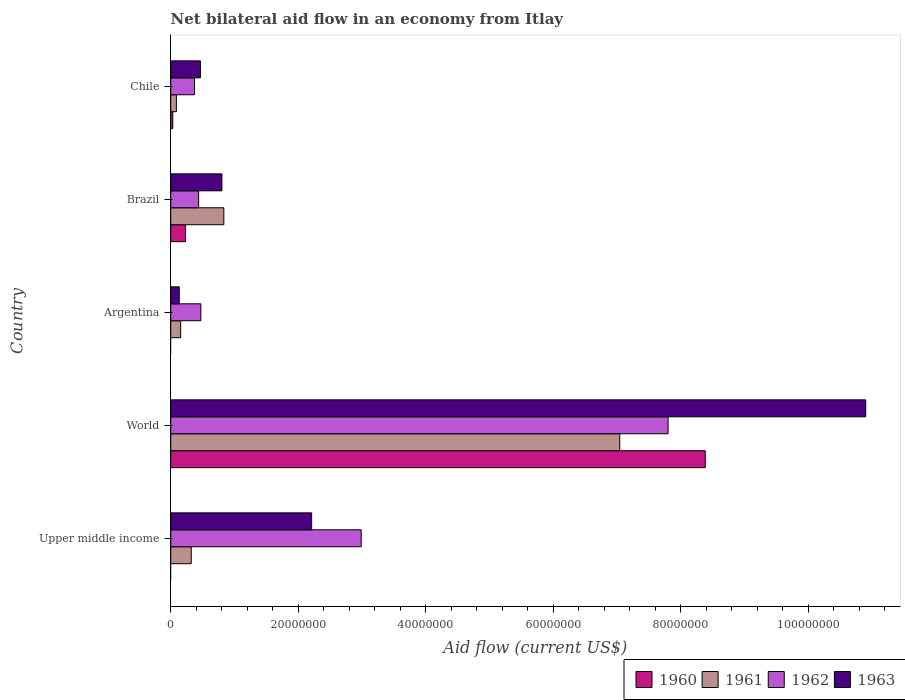How many different coloured bars are there?
Give a very brief answer. 4. How many groups of bars are there?
Your answer should be very brief. 5. Are the number of bars on each tick of the Y-axis equal?
Keep it short and to the point. No. How many bars are there on the 4th tick from the top?
Your answer should be compact. 4. In how many cases, is the number of bars for a given country not equal to the number of legend labels?
Your answer should be very brief. 2. What is the net bilateral aid flow in 1961 in Brazil?
Give a very brief answer. 8.33e+06. Across all countries, what is the maximum net bilateral aid flow in 1960?
Offer a terse response. 8.38e+07. Across all countries, what is the minimum net bilateral aid flow in 1962?
Provide a succinct answer. 3.73e+06. In which country was the net bilateral aid flow in 1962 maximum?
Provide a succinct answer. World. What is the total net bilateral aid flow in 1961 in the graph?
Your response must be concise. 8.44e+07. What is the difference between the net bilateral aid flow in 1963 in Upper middle income and that in World?
Ensure brevity in your answer.  -8.69e+07. What is the difference between the net bilateral aid flow in 1961 in Chile and the net bilateral aid flow in 1960 in Brazil?
Your answer should be very brief. -1.43e+06. What is the average net bilateral aid flow in 1962 per country?
Make the answer very short. 2.41e+07. What is the difference between the net bilateral aid flow in 1963 and net bilateral aid flow in 1962 in Brazil?
Provide a succinct answer. 3.65e+06. What is the ratio of the net bilateral aid flow in 1960 in Brazil to that in Chile?
Your answer should be very brief. 7.25. Is the net bilateral aid flow in 1962 in Chile less than that in World?
Your answer should be compact. Yes. What is the difference between the highest and the second highest net bilateral aid flow in 1963?
Keep it short and to the point. 8.69e+07. What is the difference between the highest and the lowest net bilateral aid flow in 1960?
Make the answer very short. 8.38e+07. In how many countries, is the net bilateral aid flow in 1961 greater than the average net bilateral aid flow in 1961 taken over all countries?
Your answer should be compact. 1. Is it the case that in every country, the sum of the net bilateral aid flow in 1963 and net bilateral aid flow in 1961 is greater than the net bilateral aid flow in 1960?
Provide a short and direct response. Yes. How many bars are there?
Make the answer very short. 18. Are all the bars in the graph horizontal?
Offer a terse response. Yes. Does the graph contain any zero values?
Ensure brevity in your answer.  Yes. Where does the legend appear in the graph?
Provide a short and direct response. Bottom right. How many legend labels are there?
Provide a succinct answer. 4. How are the legend labels stacked?
Offer a terse response. Horizontal. What is the title of the graph?
Your response must be concise. Net bilateral aid flow in an economy from Itlay. What is the label or title of the X-axis?
Your answer should be compact. Aid flow (current US$). What is the label or title of the Y-axis?
Offer a very short reply. Country. What is the Aid flow (current US$) of 1960 in Upper middle income?
Offer a terse response. 0. What is the Aid flow (current US$) of 1961 in Upper middle income?
Provide a succinct answer. 3.22e+06. What is the Aid flow (current US$) in 1962 in Upper middle income?
Offer a very short reply. 2.99e+07. What is the Aid flow (current US$) in 1963 in Upper middle income?
Your answer should be compact. 2.21e+07. What is the Aid flow (current US$) in 1960 in World?
Ensure brevity in your answer.  8.38e+07. What is the Aid flow (current US$) of 1961 in World?
Provide a succinct answer. 7.04e+07. What is the Aid flow (current US$) of 1962 in World?
Ensure brevity in your answer.  7.80e+07. What is the Aid flow (current US$) in 1963 in World?
Provide a short and direct response. 1.09e+08. What is the Aid flow (current US$) in 1960 in Argentina?
Your answer should be very brief. 0. What is the Aid flow (current US$) in 1961 in Argentina?
Your response must be concise. 1.56e+06. What is the Aid flow (current US$) of 1962 in Argentina?
Provide a short and direct response. 4.73e+06. What is the Aid flow (current US$) of 1963 in Argentina?
Your answer should be very brief. 1.34e+06. What is the Aid flow (current US$) in 1960 in Brazil?
Make the answer very short. 2.32e+06. What is the Aid flow (current US$) in 1961 in Brazil?
Your answer should be very brief. 8.33e+06. What is the Aid flow (current US$) of 1962 in Brazil?
Your answer should be compact. 4.38e+06. What is the Aid flow (current US$) of 1963 in Brazil?
Your response must be concise. 8.03e+06. What is the Aid flow (current US$) in 1961 in Chile?
Your response must be concise. 8.90e+05. What is the Aid flow (current US$) in 1962 in Chile?
Your answer should be very brief. 3.73e+06. What is the Aid flow (current US$) of 1963 in Chile?
Your response must be concise. 4.66e+06. Across all countries, what is the maximum Aid flow (current US$) of 1960?
Your answer should be very brief. 8.38e+07. Across all countries, what is the maximum Aid flow (current US$) in 1961?
Offer a terse response. 7.04e+07. Across all countries, what is the maximum Aid flow (current US$) in 1962?
Make the answer very short. 7.80e+07. Across all countries, what is the maximum Aid flow (current US$) in 1963?
Keep it short and to the point. 1.09e+08. Across all countries, what is the minimum Aid flow (current US$) of 1961?
Offer a terse response. 8.90e+05. Across all countries, what is the minimum Aid flow (current US$) of 1962?
Provide a succinct answer. 3.73e+06. Across all countries, what is the minimum Aid flow (current US$) of 1963?
Your answer should be very brief. 1.34e+06. What is the total Aid flow (current US$) of 1960 in the graph?
Make the answer very short. 8.65e+07. What is the total Aid flow (current US$) of 1961 in the graph?
Provide a short and direct response. 8.44e+07. What is the total Aid flow (current US$) in 1962 in the graph?
Offer a terse response. 1.21e+08. What is the total Aid flow (current US$) in 1963 in the graph?
Your answer should be compact. 1.45e+08. What is the difference between the Aid flow (current US$) of 1961 in Upper middle income and that in World?
Keep it short and to the point. -6.72e+07. What is the difference between the Aid flow (current US$) in 1962 in Upper middle income and that in World?
Your response must be concise. -4.81e+07. What is the difference between the Aid flow (current US$) of 1963 in Upper middle income and that in World?
Make the answer very short. -8.69e+07. What is the difference between the Aid flow (current US$) in 1961 in Upper middle income and that in Argentina?
Ensure brevity in your answer.  1.66e+06. What is the difference between the Aid flow (current US$) in 1962 in Upper middle income and that in Argentina?
Keep it short and to the point. 2.51e+07. What is the difference between the Aid flow (current US$) in 1963 in Upper middle income and that in Argentina?
Your response must be concise. 2.08e+07. What is the difference between the Aid flow (current US$) of 1961 in Upper middle income and that in Brazil?
Offer a very short reply. -5.11e+06. What is the difference between the Aid flow (current US$) of 1962 in Upper middle income and that in Brazil?
Ensure brevity in your answer.  2.55e+07. What is the difference between the Aid flow (current US$) of 1963 in Upper middle income and that in Brazil?
Provide a succinct answer. 1.41e+07. What is the difference between the Aid flow (current US$) in 1961 in Upper middle income and that in Chile?
Your answer should be compact. 2.33e+06. What is the difference between the Aid flow (current US$) of 1962 in Upper middle income and that in Chile?
Your answer should be compact. 2.61e+07. What is the difference between the Aid flow (current US$) of 1963 in Upper middle income and that in Chile?
Give a very brief answer. 1.74e+07. What is the difference between the Aid flow (current US$) in 1961 in World and that in Argentina?
Provide a short and direct response. 6.89e+07. What is the difference between the Aid flow (current US$) of 1962 in World and that in Argentina?
Your response must be concise. 7.33e+07. What is the difference between the Aid flow (current US$) in 1963 in World and that in Argentina?
Give a very brief answer. 1.08e+08. What is the difference between the Aid flow (current US$) in 1960 in World and that in Brazil?
Ensure brevity in your answer.  8.15e+07. What is the difference between the Aid flow (current US$) of 1961 in World and that in Brazil?
Ensure brevity in your answer.  6.21e+07. What is the difference between the Aid flow (current US$) in 1962 in World and that in Brazil?
Your answer should be compact. 7.36e+07. What is the difference between the Aid flow (current US$) in 1963 in World and that in Brazil?
Keep it short and to the point. 1.01e+08. What is the difference between the Aid flow (current US$) in 1960 in World and that in Chile?
Your answer should be compact. 8.35e+07. What is the difference between the Aid flow (current US$) of 1961 in World and that in Chile?
Your answer should be compact. 6.95e+07. What is the difference between the Aid flow (current US$) of 1962 in World and that in Chile?
Offer a terse response. 7.43e+07. What is the difference between the Aid flow (current US$) in 1963 in World and that in Chile?
Your answer should be compact. 1.04e+08. What is the difference between the Aid flow (current US$) in 1961 in Argentina and that in Brazil?
Keep it short and to the point. -6.77e+06. What is the difference between the Aid flow (current US$) of 1962 in Argentina and that in Brazil?
Your response must be concise. 3.50e+05. What is the difference between the Aid flow (current US$) of 1963 in Argentina and that in Brazil?
Your response must be concise. -6.69e+06. What is the difference between the Aid flow (current US$) in 1961 in Argentina and that in Chile?
Offer a terse response. 6.70e+05. What is the difference between the Aid flow (current US$) of 1962 in Argentina and that in Chile?
Offer a very short reply. 1.00e+06. What is the difference between the Aid flow (current US$) in 1963 in Argentina and that in Chile?
Keep it short and to the point. -3.32e+06. What is the difference between the Aid flow (current US$) in 1961 in Brazil and that in Chile?
Your answer should be compact. 7.44e+06. What is the difference between the Aid flow (current US$) in 1962 in Brazil and that in Chile?
Make the answer very short. 6.50e+05. What is the difference between the Aid flow (current US$) in 1963 in Brazil and that in Chile?
Your response must be concise. 3.37e+06. What is the difference between the Aid flow (current US$) in 1961 in Upper middle income and the Aid flow (current US$) in 1962 in World?
Offer a terse response. -7.48e+07. What is the difference between the Aid flow (current US$) of 1961 in Upper middle income and the Aid flow (current US$) of 1963 in World?
Keep it short and to the point. -1.06e+08. What is the difference between the Aid flow (current US$) of 1962 in Upper middle income and the Aid flow (current US$) of 1963 in World?
Provide a succinct answer. -7.91e+07. What is the difference between the Aid flow (current US$) of 1961 in Upper middle income and the Aid flow (current US$) of 1962 in Argentina?
Your answer should be very brief. -1.51e+06. What is the difference between the Aid flow (current US$) in 1961 in Upper middle income and the Aid flow (current US$) in 1963 in Argentina?
Your answer should be very brief. 1.88e+06. What is the difference between the Aid flow (current US$) of 1962 in Upper middle income and the Aid flow (current US$) of 1963 in Argentina?
Your answer should be very brief. 2.85e+07. What is the difference between the Aid flow (current US$) of 1961 in Upper middle income and the Aid flow (current US$) of 1962 in Brazil?
Your answer should be very brief. -1.16e+06. What is the difference between the Aid flow (current US$) of 1961 in Upper middle income and the Aid flow (current US$) of 1963 in Brazil?
Your response must be concise. -4.81e+06. What is the difference between the Aid flow (current US$) in 1962 in Upper middle income and the Aid flow (current US$) in 1963 in Brazil?
Your answer should be very brief. 2.18e+07. What is the difference between the Aid flow (current US$) in 1961 in Upper middle income and the Aid flow (current US$) in 1962 in Chile?
Make the answer very short. -5.10e+05. What is the difference between the Aid flow (current US$) of 1961 in Upper middle income and the Aid flow (current US$) of 1963 in Chile?
Your answer should be very brief. -1.44e+06. What is the difference between the Aid flow (current US$) of 1962 in Upper middle income and the Aid flow (current US$) of 1963 in Chile?
Ensure brevity in your answer.  2.52e+07. What is the difference between the Aid flow (current US$) of 1960 in World and the Aid flow (current US$) of 1961 in Argentina?
Your response must be concise. 8.23e+07. What is the difference between the Aid flow (current US$) in 1960 in World and the Aid flow (current US$) in 1962 in Argentina?
Ensure brevity in your answer.  7.91e+07. What is the difference between the Aid flow (current US$) of 1960 in World and the Aid flow (current US$) of 1963 in Argentina?
Your response must be concise. 8.25e+07. What is the difference between the Aid flow (current US$) of 1961 in World and the Aid flow (current US$) of 1962 in Argentina?
Your response must be concise. 6.57e+07. What is the difference between the Aid flow (current US$) of 1961 in World and the Aid flow (current US$) of 1963 in Argentina?
Offer a terse response. 6.91e+07. What is the difference between the Aid flow (current US$) of 1962 in World and the Aid flow (current US$) of 1963 in Argentina?
Offer a terse response. 7.67e+07. What is the difference between the Aid flow (current US$) in 1960 in World and the Aid flow (current US$) in 1961 in Brazil?
Your answer should be compact. 7.55e+07. What is the difference between the Aid flow (current US$) of 1960 in World and the Aid flow (current US$) of 1962 in Brazil?
Offer a very short reply. 7.94e+07. What is the difference between the Aid flow (current US$) in 1960 in World and the Aid flow (current US$) in 1963 in Brazil?
Offer a terse response. 7.58e+07. What is the difference between the Aid flow (current US$) in 1961 in World and the Aid flow (current US$) in 1962 in Brazil?
Ensure brevity in your answer.  6.60e+07. What is the difference between the Aid flow (current US$) of 1961 in World and the Aid flow (current US$) of 1963 in Brazil?
Give a very brief answer. 6.24e+07. What is the difference between the Aid flow (current US$) in 1962 in World and the Aid flow (current US$) in 1963 in Brazil?
Offer a very short reply. 7.00e+07. What is the difference between the Aid flow (current US$) in 1960 in World and the Aid flow (current US$) in 1961 in Chile?
Your answer should be compact. 8.29e+07. What is the difference between the Aid flow (current US$) of 1960 in World and the Aid flow (current US$) of 1962 in Chile?
Give a very brief answer. 8.01e+07. What is the difference between the Aid flow (current US$) of 1960 in World and the Aid flow (current US$) of 1963 in Chile?
Your response must be concise. 7.92e+07. What is the difference between the Aid flow (current US$) of 1961 in World and the Aid flow (current US$) of 1962 in Chile?
Offer a terse response. 6.67e+07. What is the difference between the Aid flow (current US$) of 1961 in World and the Aid flow (current US$) of 1963 in Chile?
Offer a very short reply. 6.58e+07. What is the difference between the Aid flow (current US$) in 1962 in World and the Aid flow (current US$) in 1963 in Chile?
Your answer should be very brief. 7.33e+07. What is the difference between the Aid flow (current US$) in 1961 in Argentina and the Aid flow (current US$) in 1962 in Brazil?
Provide a succinct answer. -2.82e+06. What is the difference between the Aid flow (current US$) in 1961 in Argentina and the Aid flow (current US$) in 1963 in Brazil?
Keep it short and to the point. -6.47e+06. What is the difference between the Aid flow (current US$) in 1962 in Argentina and the Aid flow (current US$) in 1963 in Brazil?
Ensure brevity in your answer.  -3.30e+06. What is the difference between the Aid flow (current US$) of 1961 in Argentina and the Aid flow (current US$) of 1962 in Chile?
Offer a terse response. -2.17e+06. What is the difference between the Aid flow (current US$) in 1961 in Argentina and the Aid flow (current US$) in 1963 in Chile?
Offer a terse response. -3.10e+06. What is the difference between the Aid flow (current US$) in 1962 in Argentina and the Aid flow (current US$) in 1963 in Chile?
Make the answer very short. 7.00e+04. What is the difference between the Aid flow (current US$) of 1960 in Brazil and the Aid flow (current US$) of 1961 in Chile?
Keep it short and to the point. 1.43e+06. What is the difference between the Aid flow (current US$) of 1960 in Brazil and the Aid flow (current US$) of 1962 in Chile?
Give a very brief answer. -1.41e+06. What is the difference between the Aid flow (current US$) in 1960 in Brazil and the Aid flow (current US$) in 1963 in Chile?
Offer a very short reply. -2.34e+06. What is the difference between the Aid flow (current US$) in 1961 in Brazil and the Aid flow (current US$) in 1962 in Chile?
Offer a very short reply. 4.60e+06. What is the difference between the Aid flow (current US$) in 1961 in Brazil and the Aid flow (current US$) in 1963 in Chile?
Make the answer very short. 3.67e+06. What is the difference between the Aid flow (current US$) in 1962 in Brazil and the Aid flow (current US$) in 1963 in Chile?
Your answer should be very brief. -2.80e+05. What is the average Aid flow (current US$) in 1960 per country?
Your answer should be very brief. 1.73e+07. What is the average Aid flow (current US$) in 1961 per country?
Make the answer very short. 1.69e+07. What is the average Aid flow (current US$) in 1962 per country?
Your answer should be very brief. 2.41e+07. What is the average Aid flow (current US$) in 1963 per country?
Keep it short and to the point. 2.90e+07. What is the difference between the Aid flow (current US$) of 1961 and Aid flow (current US$) of 1962 in Upper middle income?
Give a very brief answer. -2.66e+07. What is the difference between the Aid flow (current US$) in 1961 and Aid flow (current US$) in 1963 in Upper middle income?
Offer a very short reply. -1.89e+07. What is the difference between the Aid flow (current US$) of 1962 and Aid flow (current US$) of 1963 in Upper middle income?
Provide a succinct answer. 7.77e+06. What is the difference between the Aid flow (current US$) of 1960 and Aid flow (current US$) of 1961 in World?
Offer a terse response. 1.34e+07. What is the difference between the Aid flow (current US$) in 1960 and Aid flow (current US$) in 1962 in World?
Offer a terse response. 5.83e+06. What is the difference between the Aid flow (current US$) in 1960 and Aid flow (current US$) in 1963 in World?
Offer a terse response. -2.52e+07. What is the difference between the Aid flow (current US$) in 1961 and Aid flow (current US$) in 1962 in World?
Offer a terse response. -7.58e+06. What is the difference between the Aid flow (current US$) in 1961 and Aid flow (current US$) in 1963 in World?
Make the answer very short. -3.86e+07. What is the difference between the Aid flow (current US$) of 1962 and Aid flow (current US$) of 1963 in World?
Your answer should be very brief. -3.10e+07. What is the difference between the Aid flow (current US$) in 1961 and Aid flow (current US$) in 1962 in Argentina?
Your answer should be very brief. -3.17e+06. What is the difference between the Aid flow (current US$) of 1962 and Aid flow (current US$) of 1963 in Argentina?
Offer a terse response. 3.39e+06. What is the difference between the Aid flow (current US$) in 1960 and Aid flow (current US$) in 1961 in Brazil?
Your response must be concise. -6.01e+06. What is the difference between the Aid flow (current US$) in 1960 and Aid flow (current US$) in 1962 in Brazil?
Your answer should be very brief. -2.06e+06. What is the difference between the Aid flow (current US$) in 1960 and Aid flow (current US$) in 1963 in Brazil?
Give a very brief answer. -5.71e+06. What is the difference between the Aid flow (current US$) of 1961 and Aid flow (current US$) of 1962 in Brazil?
Give a very brief answer. 3.95e+06. What is the difference between the Aid flow (current US$) of 1961 and Aid flow (current US$) of 1963 in Brazil?
Ensure brevity in your answer.  3.00e+05. What is the difference between the Aid flow (current US$) of 1962 and Aid flow (current US$) of 1963 in Brazil?
Keep it short and to the point. -3.65e+06. What is the difference between the Aid flow (current US$) in 1960 and Aid flow (current US$) in 1961 in Chile?
Offer a very short reply. -5.70e+05. What is the difference between the Aid flow (current US$) in 1960 and Aid flow (current US$) in 1962 in Chile?
Offer a terse response. -3.41e+06. What is the difference between the Aid flow (current US$) of 1960 and Aid flow (current US$) of 1963 in Chile?
Offer a very short reply. -4.34e+06. What is the difference between the Aid flow (current US$) in 1961 and Aid flow (current US$) in 1962 in Chile?
Make the answer very short. -2.84e+06. What is the difference between the Aid flow (current US$) in 1961 and Aid flow (current US$) in 1963 in Chile?
Your answer should be very brief. -3.77e+06. What is the difference between the Aid flow (current US$) in 1962 and Aid flow (current US$) in 1963 in Chile?
Offer a very short reply. -9.30e+05. What is the ratio of the Aid flow (current US$) in 1961 in Upper middle income to that in World?
Keep it short and to the point. 0.05. What is the ratio of the Aid flow (current US$) in 1962 in Upper middle income to that in World?
Give a very brief answer. 0.38. What is the ratio of the Aid flow (current US$) in 1963 in Upper middle income to that in World?
Ensure brevity in your answer.  0.2. What is the ratio of the Aid flow (current US$) in 1961 in Upper middle income to that in Argentina?
Ensure brevity in your answer.  2.06. What is the ratio of the Aid flow (current US$) of 1962 in Upper middle income to that in Argentina?
Ensure brevity in your answer.  6.32. What is the ratio of the Aid flow (current US$) of 1963 in Upper middle income to that in Argentina?
Your response must be concise. 16.49. What is the ratio of the Aid flow (current US$) in 1961 in Upper middle income to that in Brazil?
Offer a terse response. 0.39. What is the ratio of the Aid flow (current US$) of 1962 in Upper middle income to that in Brazil?
Ensure brevity in your answer.  6.82. What is the ratio of the Aid flow (current US$) of 1963 in Upper middle income to that in Brazil?
Make the answer very short. 2.75. What is the ratio of the Aid flow (current US$) in 1961 in Upper middle income to that in Chile?
Ensure brevity in your answer.  3.62. What is the ratio of the Aid flow (current US$) of 1962 in Upper middle income to that in Chile?
Ensure brevity in your answer.  8.01. What is the ratio of the Aid flow (current US$) in 1963 in Upper middle income to that in Chile?
Keep it short and to the point. 4.74. What is the ratio of the Aid flow (current US$) of 1961 in World to that in Argentina?
Your response must be concise. 45.14. What is the ratio of the Aid flow (current US$) in 1962 in World to that in Argentina?
Make the answer very short. 16.49. What is the ratio of the Aid flow (current US$) of 1963 in World to that in Argentina?
Your answer should be compact. 81.34. What is the ratio of the Aid flow (current US$) in 1960 in World to that in Brazil?
Your answer should be compact. 36.13. What is the ratio of the Aid flow (current US$) in 1961 in World to that in Brazil?
Your answer should be compact. 8.45. What is the ratio of the Aid flow (current US$) in 1962 in World to that in Brazil?
Provide a succinct answer. 17.81. What is the ratio of the Aid flow (current US$) in 1963 in World to that in Brazil?
Your response must be concise. 13.57. What is the ratio of the Aid flow (current US$) of 1960 in World to that in Chile?
Offer a very short reply. 261.97. What is the ratio of the Aid flow (current US$) in 1961 in World to that in Chile?
Offer a terse response. 79.12. What is the ratio of the Aid flow (current US$) in 1962 in World to that in Chile?
Provide a short and direct response. 20.91. What is the ratio of the Aid flow (current US$) of 1963 in World to that in Chile?
Make the answer very short. 23.39. What is the ratio of the Aid flow (current US$) in 1961 in Argentina to that in Brazil?
Offer a very short reply. 0.19. What is the ratio of the Aid flow (current US$) in 1962 in Argentina to that in Brazil?
Give a very brief answer. 1.08. What is the ratio of the Aid flow (current US$) of 1963 in Argentina to that in Brazil?
Your response must be concise. 0.17. What is the ratio of the Aid flow (current US$) of 1961 in Argentina to that in Chile?
Keep it short and to the point. 1.75. What is the ratio of the Aid flow (current US$) of 1962 in Argentina to that in Chile?
Your answer should be compact. 1.27. What is the ratio of the Aid flow (current US$) in 1963 in Argentina to that in Chile?
Offer a terse response. 0.29. What is the ratio of the Aid flow (current US$) of 1960 in Brazil to that in Chile?
Give a very brief answer. 7.25. What is the ratio of the Aid flow (current US$) in 1961 in Brazil to that in Chile?
Give a very brief answer. 9.36. What is the ratio of the Aid flow (current US$) in 1962 in Brazil to that in Chile?
Offer a terse response. 1.17. What is the ratio of the Aid flow (current US$) in 1963 in Brazil to that in Chile?
Provide a short and direct response. 1.72. What is the difference between the highest and the second highest Aid flow (current US$) of 1960?
Your answer should be very brief. 8.15e+07. What is the difference between the highest and the second highest Aid flow (current US$) in 1961?
Keep it short and to the point. 6.21e+07. What is the difference between the highest and the second highest Aid flow (current US$) in 1962?
Provide a short and direct response. 4.81e+07. What is the difference between the highest and the second highest Aid flow (current US$) in 1963?
Your answer should be very brief. 8.69e+07. What is the difference between the highest and the lowest Aid flow (current US$) in 1960?
Ensure brevity in your answer.  8.38e+07. What is the difference between the highest and the lowest Aid flow (current US$) in 1961?
Offer a terse response. 6.95e+07. What is the difference between the highest and the lowest Aid flow (current US$) in 1962?
Keep it short and to the point. 7.43e+07. What is the difference between the highest and the lowest Aid flow (current US$) in 1963?
Give a very brief answer. 1.08e+08. 